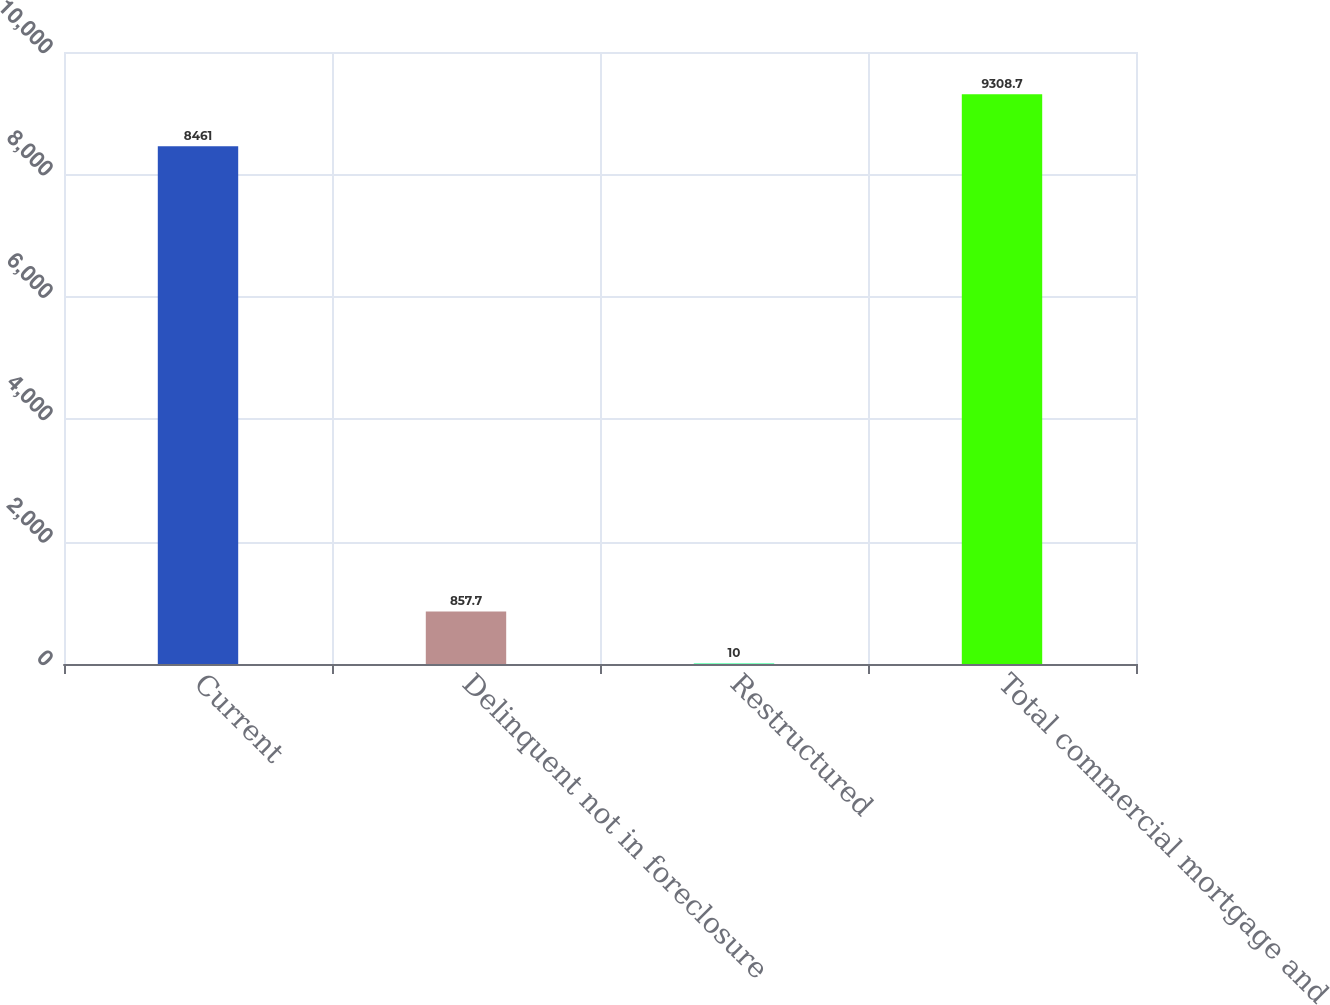<chart> <loc_0><loc_0><loc_500><loc_500><bar_chart><fcel>Current<fcel>Delinquent not in foreclosure<fcel>Restructured<fcel>Total commercial mortgage and<nl><fcel>8461<fcel>857.7<fcel>10<fcel>9308.7<nl></chart> 